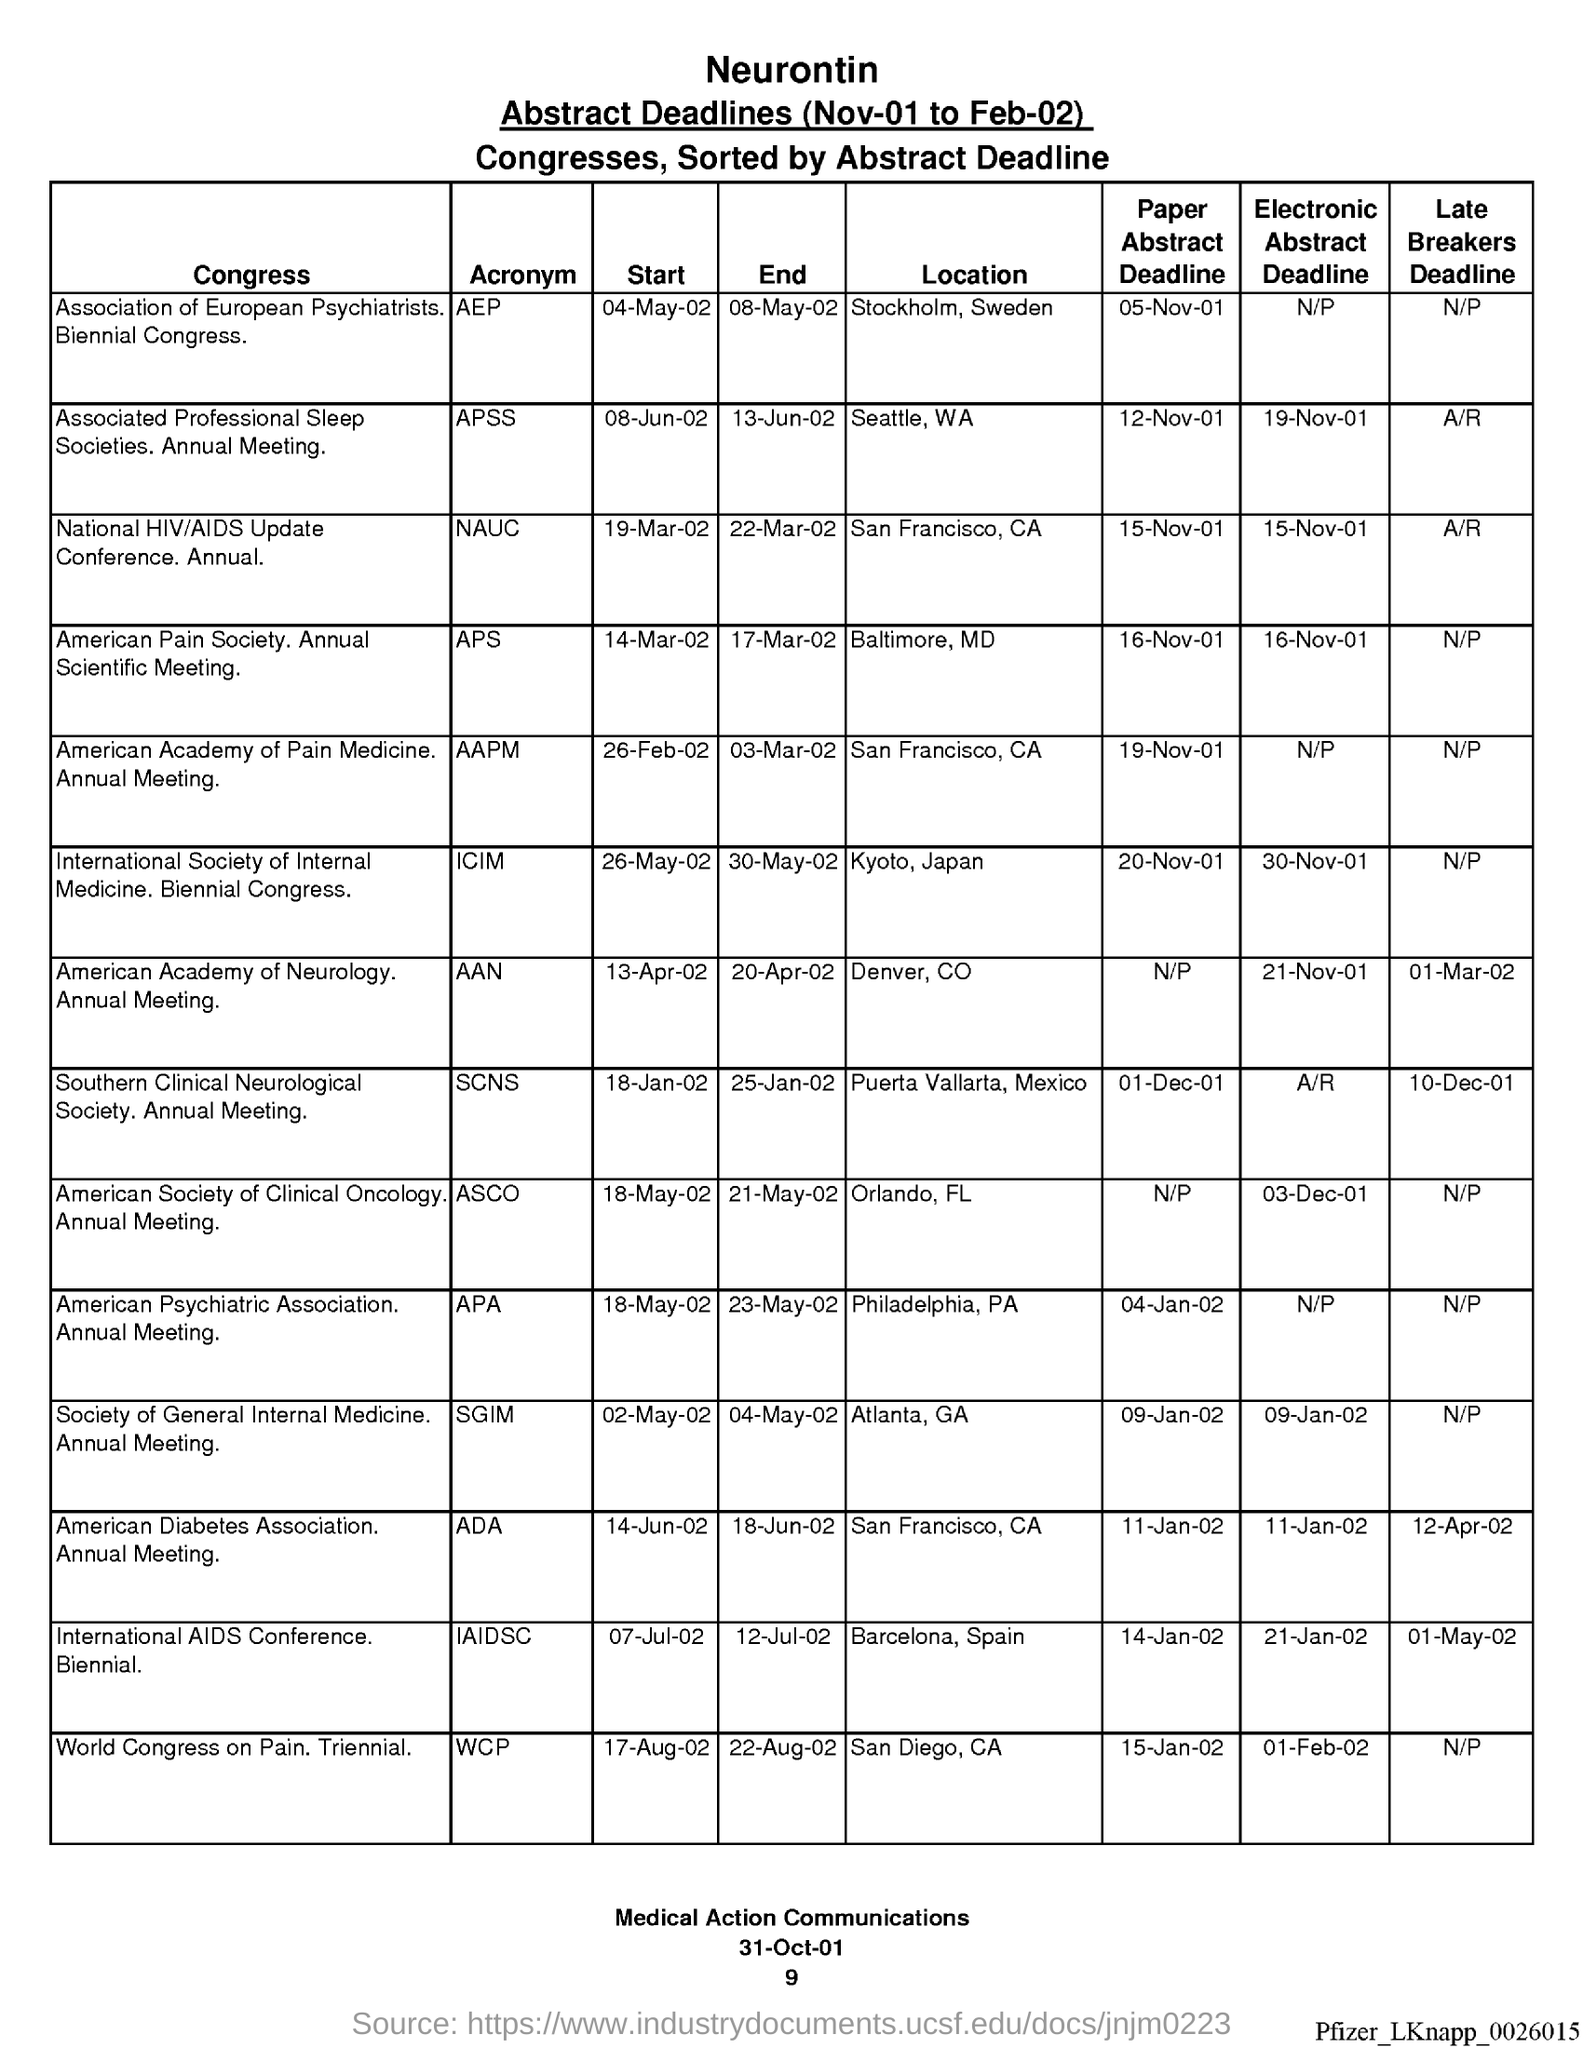What is the acronym for association of european psychiatrists ?
Offer a very short reply. AEP. What is the acronym for associated professional sleep societies ?
Your answer should be very brief. APSS. What is the acronym for national hiv/ aids update ?
Offer a terse response. NAUC. What is the acronym for american pain society ?
Offer a very short reply. APS. What is the acronym for american academy of pain medicine ?
Offer a terse response. AAPM. What is the acronym for international society of internal medicine ?
Provide a succinct answer. ICIM. What is the acronym for american academy of neurology ?
Offer a very short reply. AAN. What is the acronym for southern clinical neurological society ?
Your answer should be very brief. SCNS. What is the acronym for american diabetes association ?
Make the answer very short. ADA. 